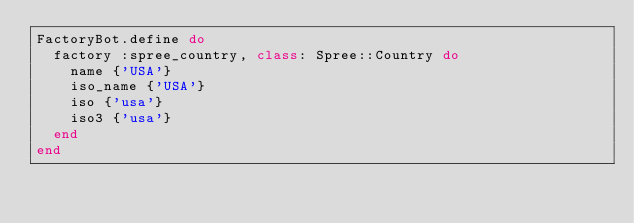<code> <loc_0><loc_0><loc_500><loc_500><_Ruby_>FactoryBot.define do
  factory :spree_country, class: Spree::Country do
    name {'USA'}
    iso_name {'USA'}
    iso {'usa'}
    iso3 {'usa'}
  end
end
</code> 